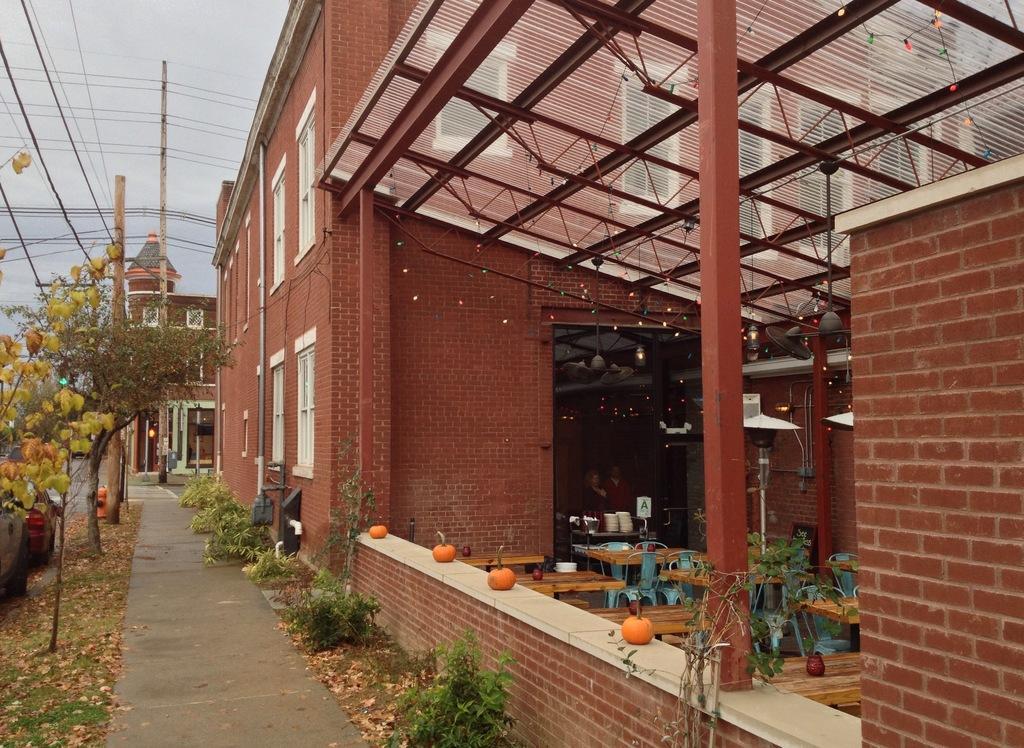How would you summarize this image in a sentence or two? In this image we can see a building with windows, roof and also decorated with some lights. We can also see some pumpkins placed aside, some chairs, plates on a table, a table fan, some plants, poles, a ceiling fan and two persons standing inside the building. On the left side we can see some plants, trees, a pathway, some poles, a car parked aside, some wires and the sky which looks cloudy. 